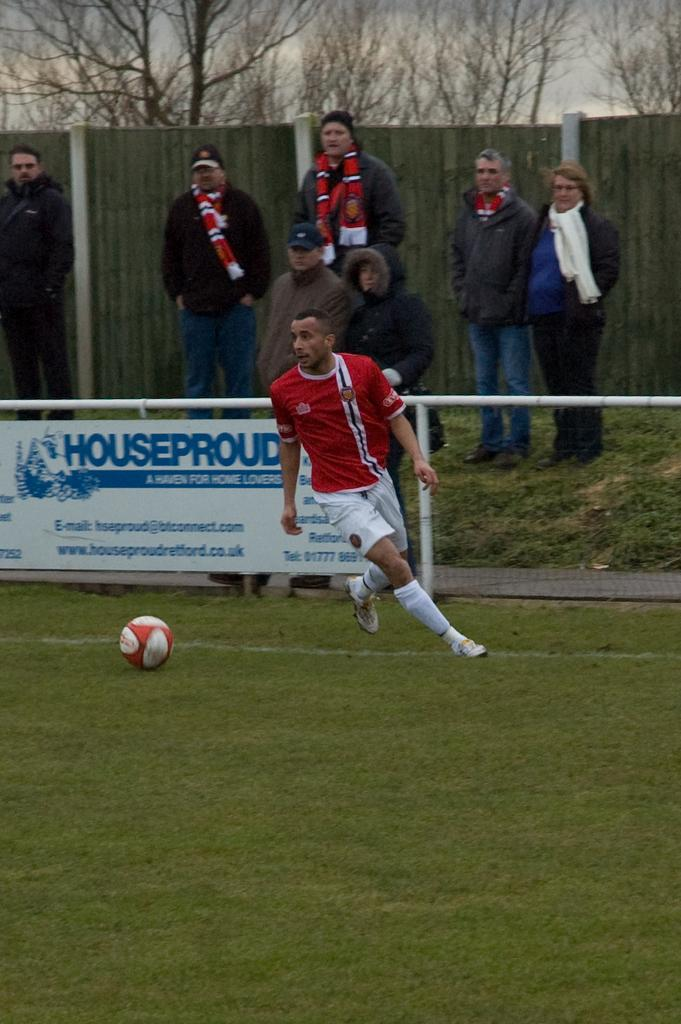What is the man in the image doing? The man in the image is running. What object is on the ground in the image? There is a ball on the ground in the image. What can be seen in the background of the image? In the background of the image, there is a hoarding, poles, men standing on the ground, a fence, trees, and clouds in the sky. Can you tell me how many toads are present in the image? There are no toads present in the image. Who is the representative of the group in the image? The image does not depict a group or a representative; it only shows a man running and a ball on the ground. 